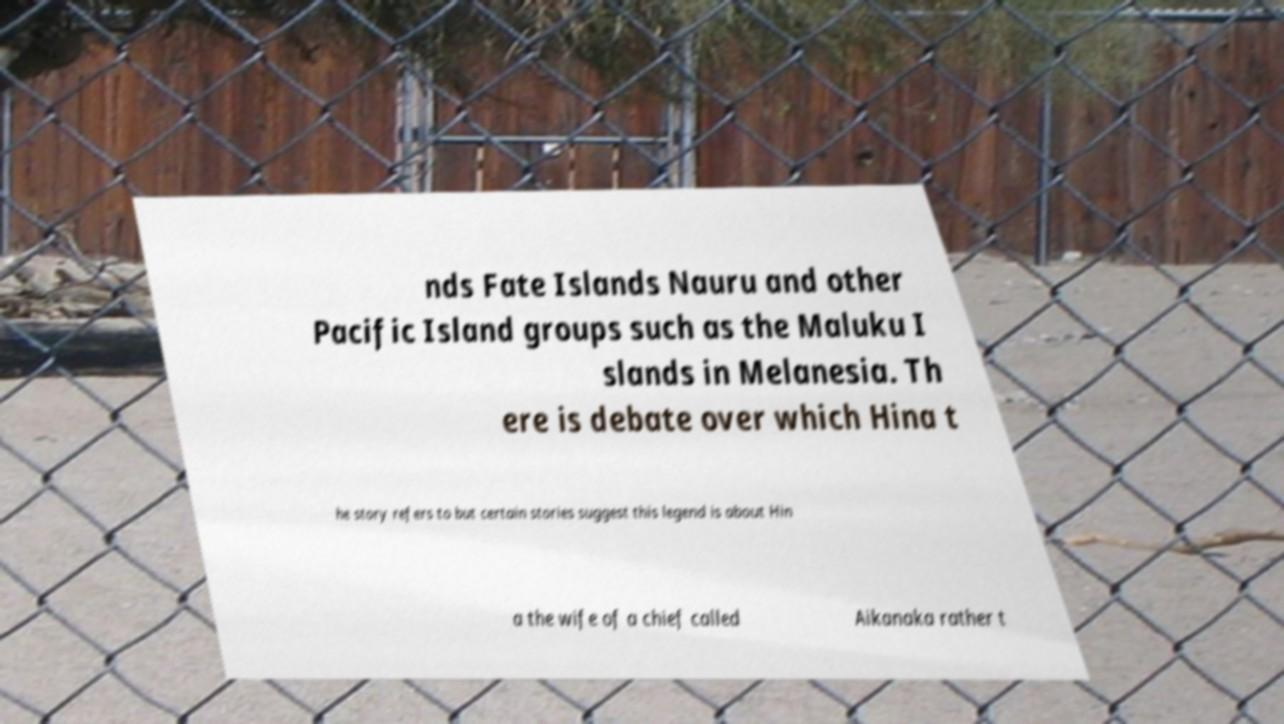Could you extract and type out the text from this image? nds Fate Islands Nauru and other Pacific Island groups such as the Maluku I slands in Melanesia. Th ere is debate over which Hina t he story refers to but certain stories suggest this legend is about Hin a the wife of a chief called Aikanaka rather t 